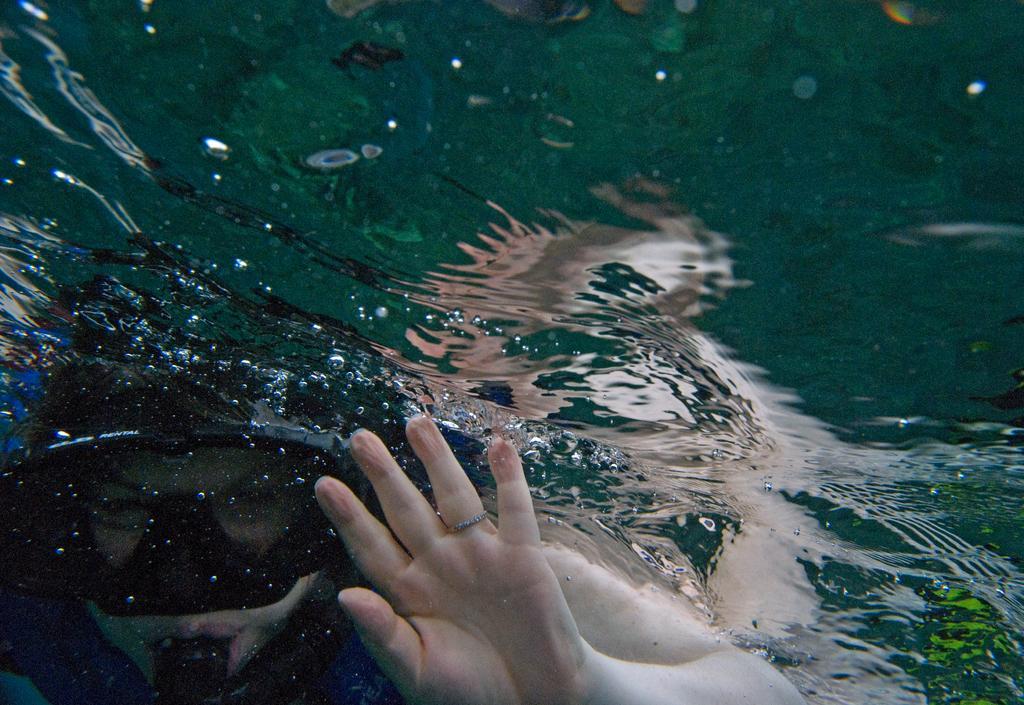In one or two sentences, can you explain what this image depicts? In this image we can see a person in the water. Here we can see the hand of a person. 